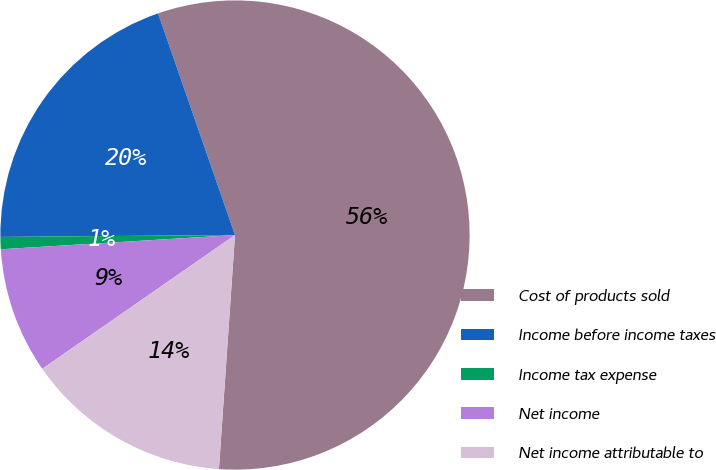Convert chart to OTSL. <chart><loc_0><loc_0><loc_500><loc_500><pie_chart><fcel>Cost of products sold<fcel>Income before income taxes<fcel>Income tax expense<fcel>Net income<fcel>Net income attributable to<nl><fcel>56.41%<fcel>19.81%<fcel>0.84%<fcel>8.69%<fcel>14.25%<nl></chart> 